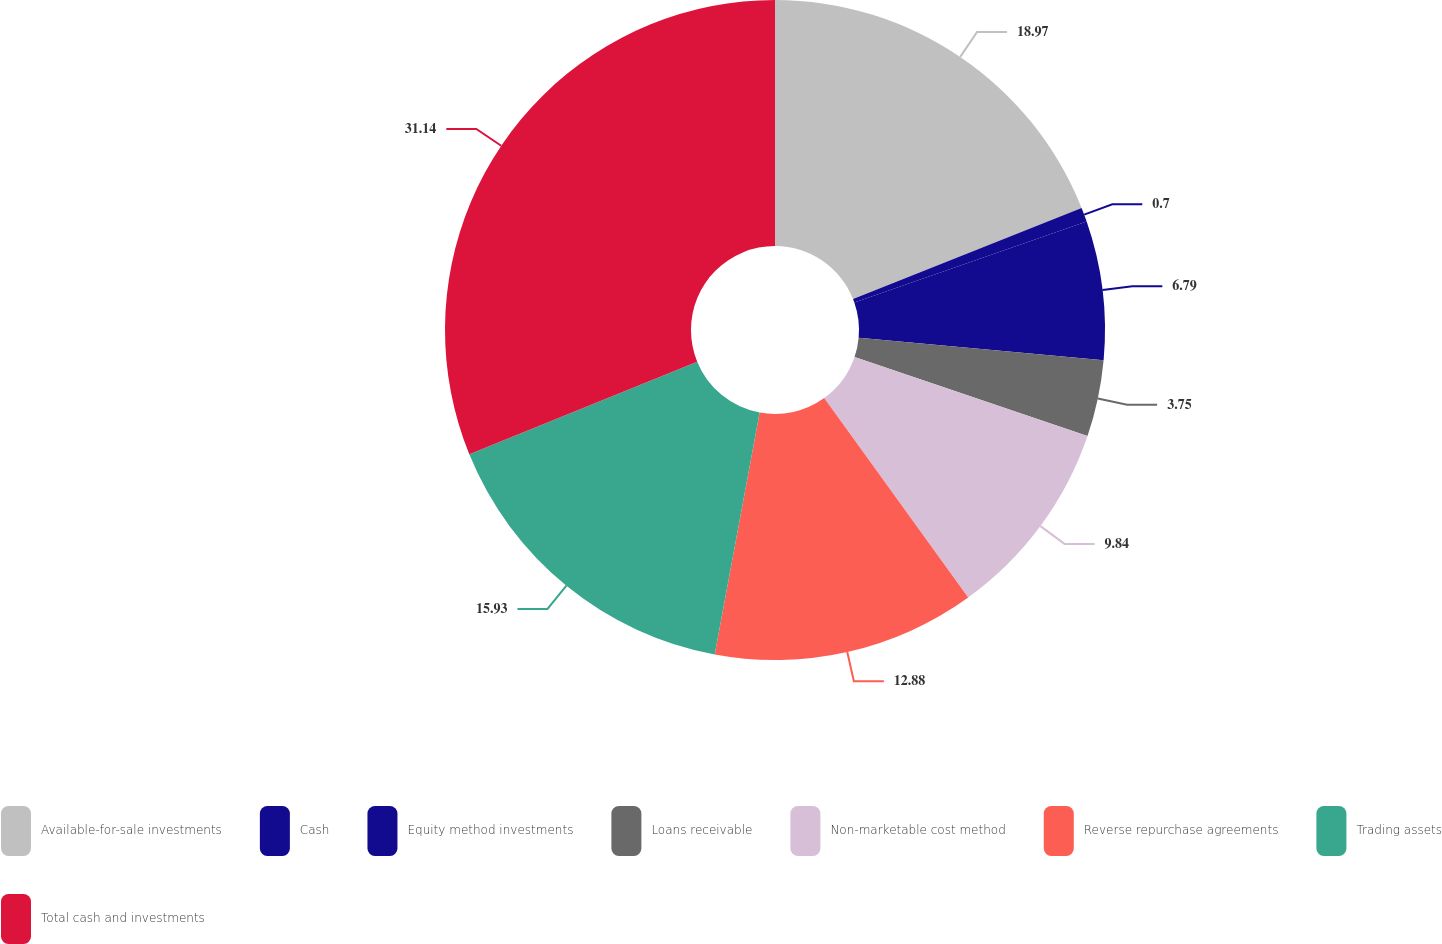Convert chart to OTSL. <chart><loc_0><loc_0><loc_500><loc_500><pie_chart><fcel>Available-for-sale investments<fcel>Cash<fcel>Equity method investments<fcel>Loans receivable<fcel>Non-marketable cost method<fcel>Reverse repurchase agreements<fcel>Trading assets<fcel>Total cash and investments<nl><fcel>18.97%<fcel>0.7%<fcel>6.79%<fcel>3.75%<fcel>9.84%<fcel>12.88%<fcel>15.93%<fcel>31.15%<nl></chart> 